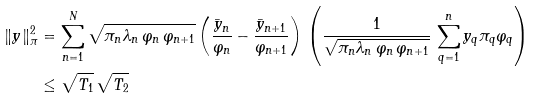<formula> <loc_0><loc_0><loc_500><loc_500>\| y \| ^ { 2 } _ { \pi } & = \sum _ { n = 1 } ^ { N } \sqrt { \pi _ { n } \lambda _ { n } \, \varphi _ { n } \, \varphi _ { n + 1 } } \left ( \frac { \bar { y } _ { n } } { \varphi _ { n } } - \frac { \bar { y } _ { n + 1 } } { \varphi _ { n + 1 } } \right ) \, \left ( \frac { 1 } { \sqrt { \pi _ { n } \lambda _ { n } \, \varphi _ { n } \, \varphi _ { n + 1 } } } \, \sum _ { q = 1 } ^ { n } y _ { q } \pi _ { q } \varphi _ { q } \right ) \\ & \leq \sqrt { T _ { 1 } } \, \sqrt { T _ { 2 } }</formula> 